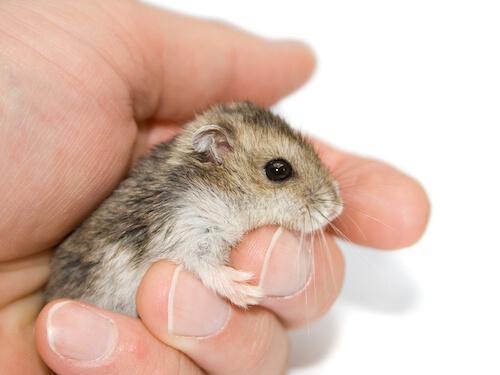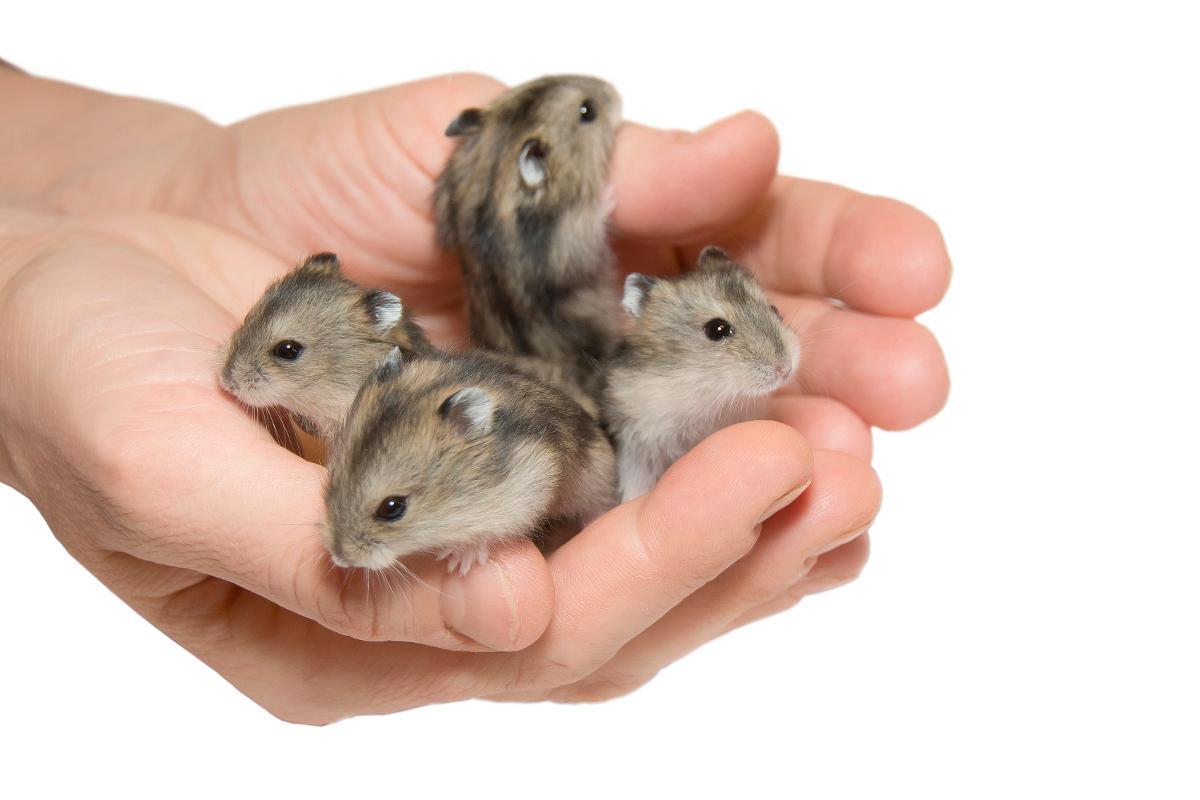The first image is the image on the left, the second image is the image on the right. Examine the images to the left and right. Is the description "One image shows a hand holding more than one small rodent." accurate? Answer yes or no. Yes. The first image is the image on the left, the second image is the image on the right. Assess this claim about the two images: "A human hand is holding some hamsters.". Correct or not? Answer yes or no. Yes. 